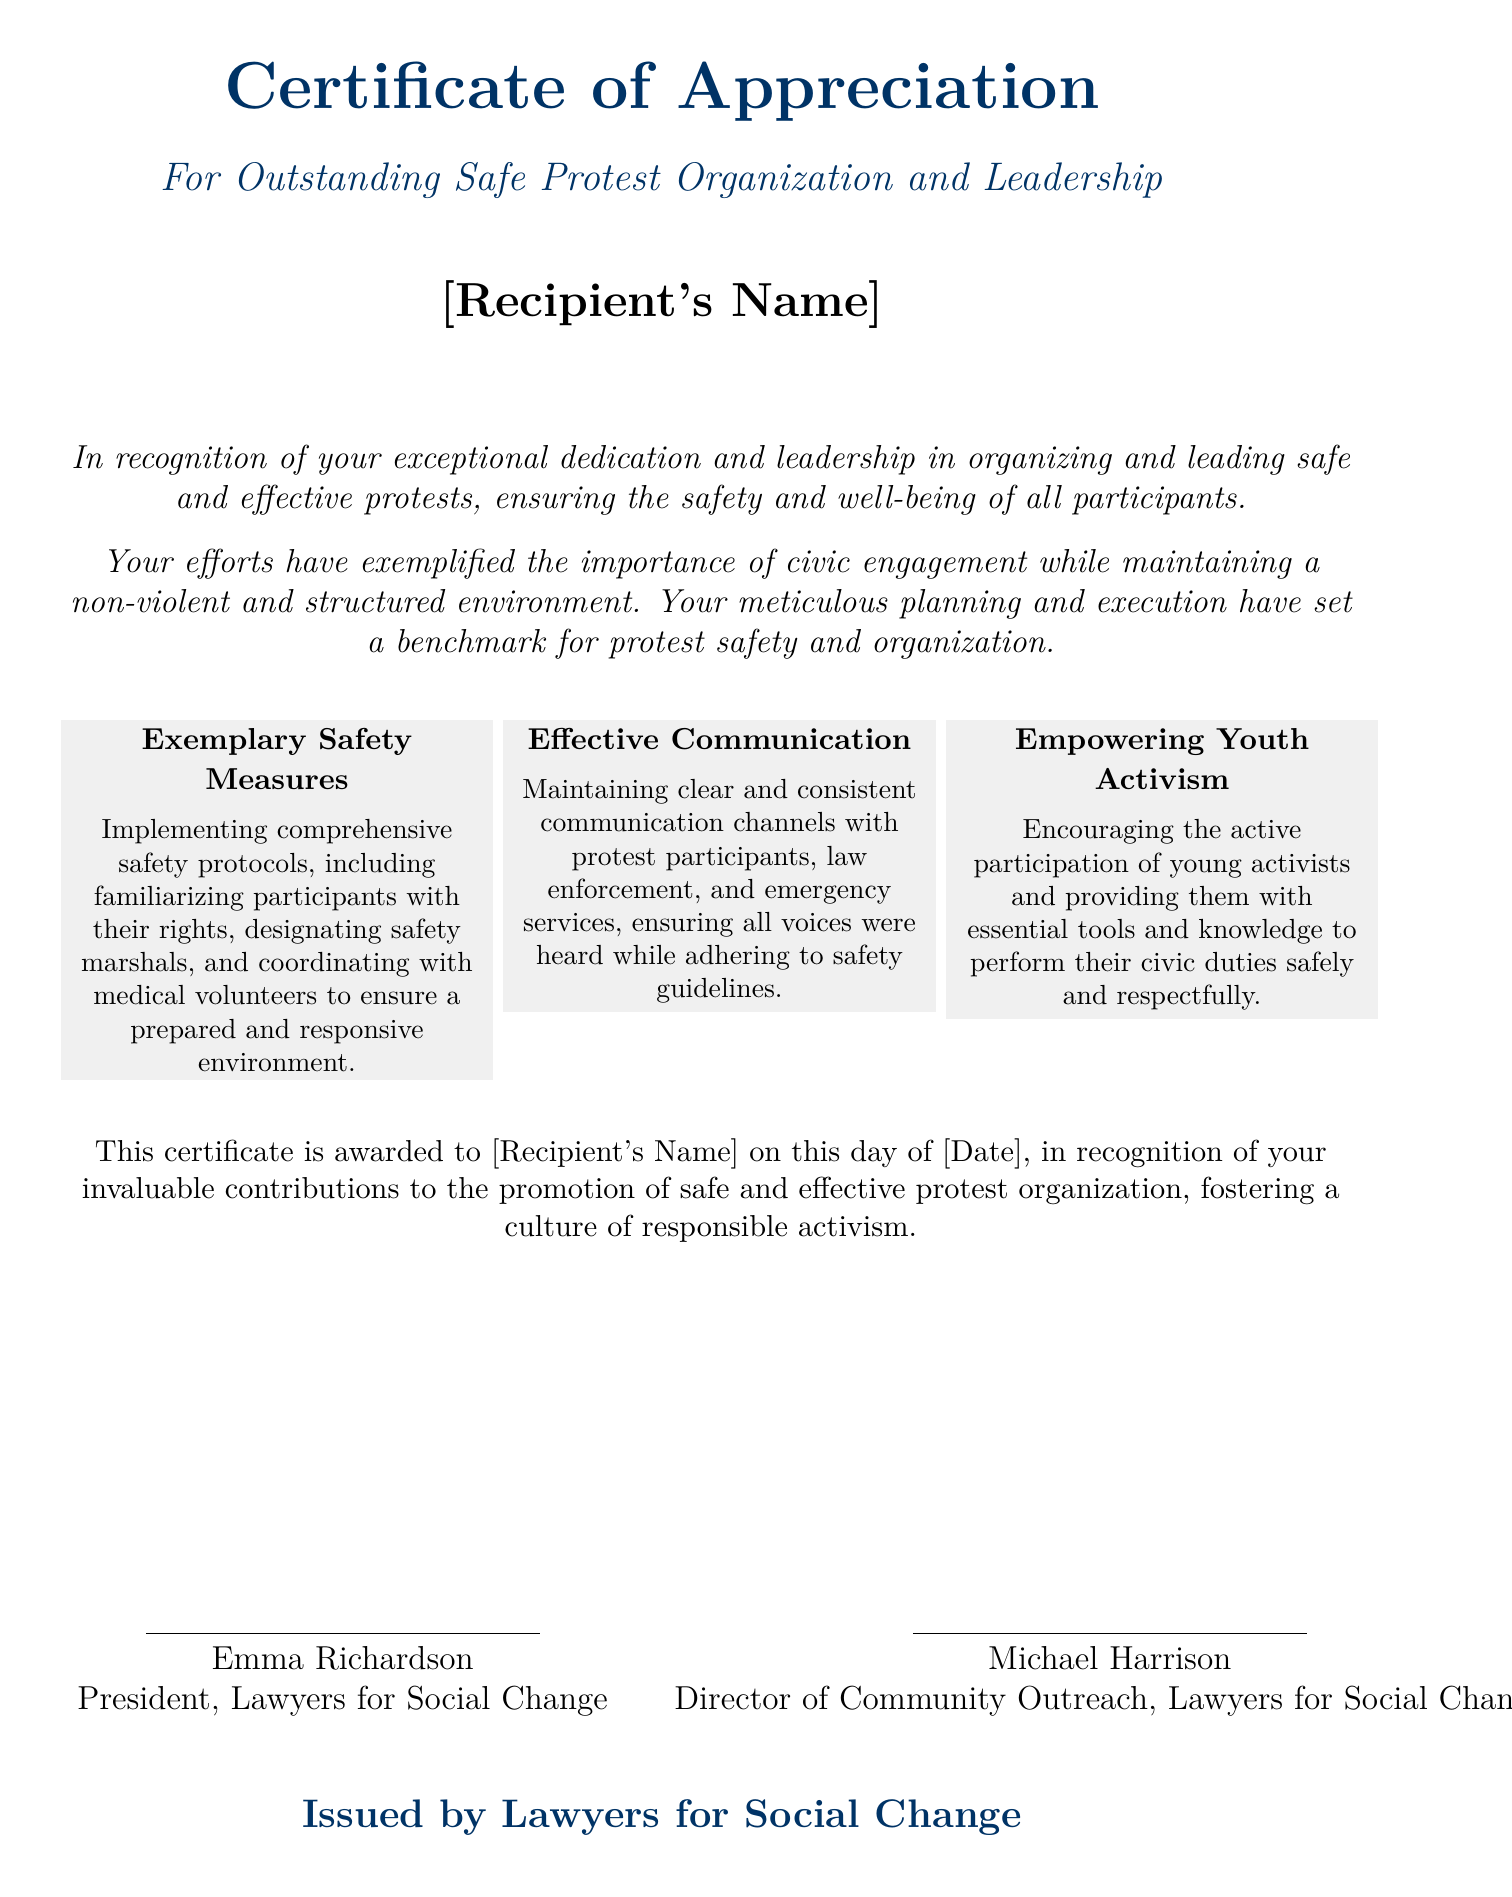What is the title of the certificate? The title of the certificate is stated at the top of the document, which is "Certificate of Appreciation".
Answer: Certificate of Appreciation Who is the certificate awarded to? The recipient's name is indicated in the document as "[Recipient's Name]".
Answer: [Recipient's Name] What organization issued the certificate? The issuer of the certificate is mentioned at the bottom, stating "Issued by Lawyers for Social Change".
Answer: Lawyers for Social Change What date is the certificate awarded? The date of the award is indicated with the placeholder "[Date]" in the document.
Answer: [Date] Name one aspect of the "Exemplary Safety Measures". One aspect can be found in the text about comprehensive safety protocols, specifically "familiarizing participants with their rights".
Answer: familiarizing participants with their rights What is one of the goals of empowering youth activism stated in the document? The document mentions that the empowerment goal is to provide essential tools and knowledge to perform civic duties safely and respectfully.
Answer: perform civic duties safely How many individuals signed the certificate? The certificate has signatures from two individuals as indicated in the signature section.
Answer: Two What type of environment does the document emphasize for protests? The document emphasizes the importance of maintaining a "non-violent and structured environment" for protests.
Answer: non-violent and structured environment 